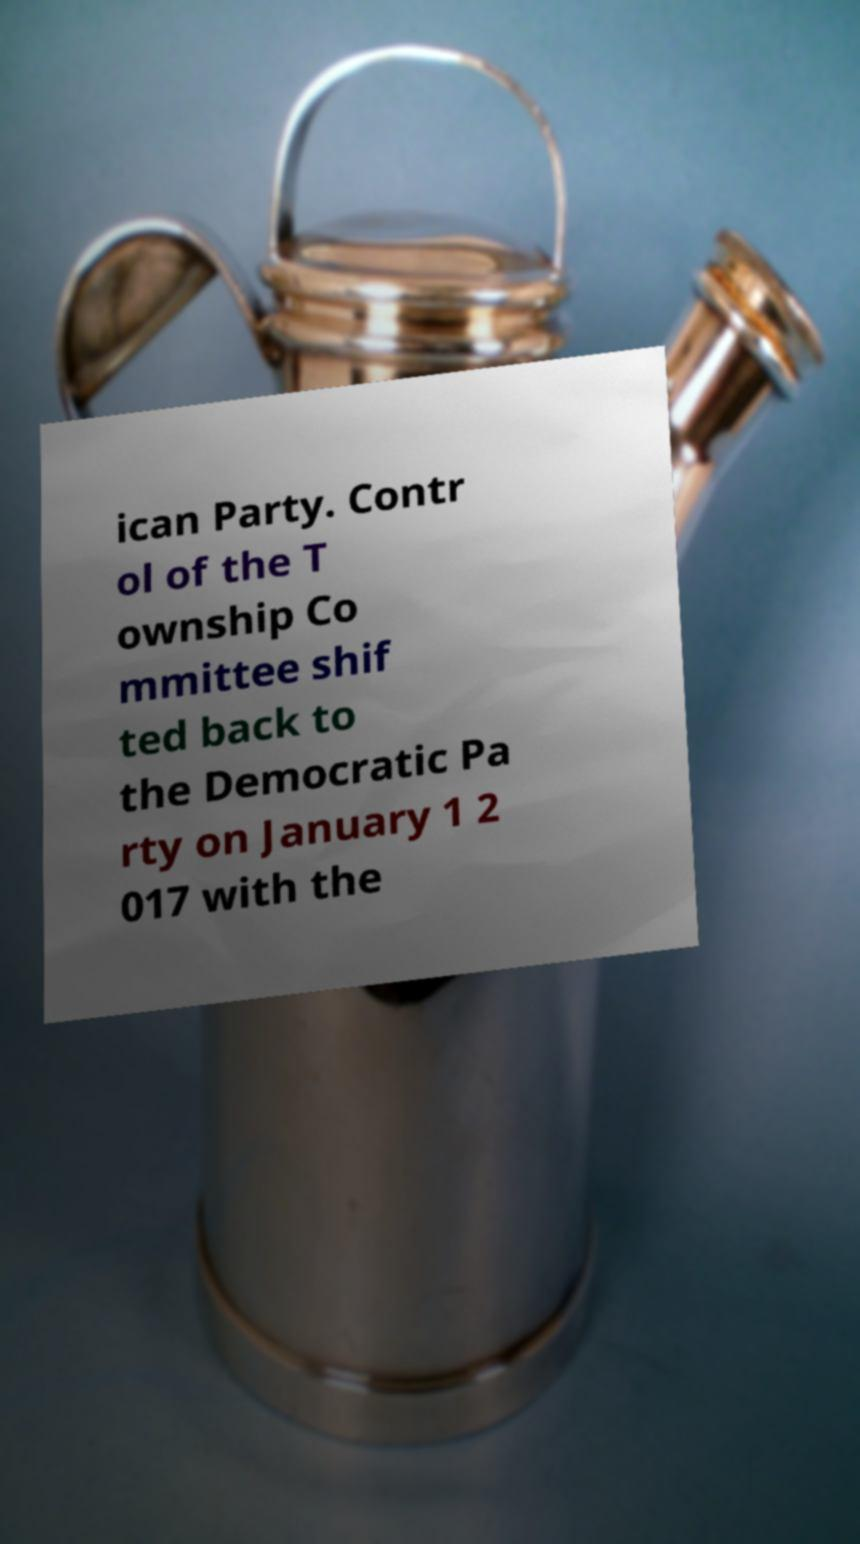Could you extract and type out the text from this image? ican Party. Contr ol of the T ownship Co mmittee shif ted back to the Democratic Pa rty on January 1 2 017 with the 